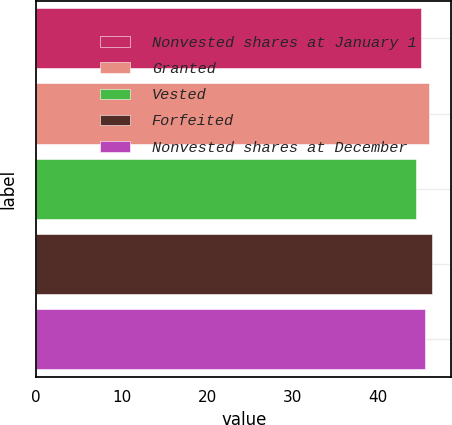<chart> <loc_0><loc_0><loc_500><loc_500><bar_chart><fcel>Nonvested shares at January 1<fcel>Granted<fcel>Vested<fcel>Forfeited<fcel>Nonvested shares at December<nl><fcel>44.96<fcel>45.99<fcel>44.4<fcel>46.25<fcel>45.42<nl></chart> 